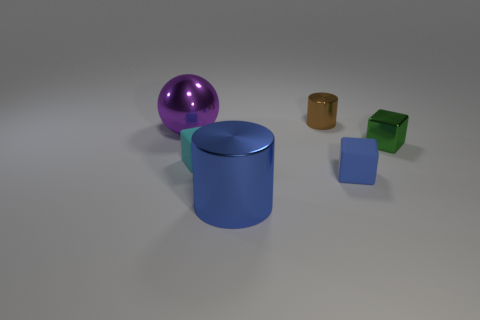Subtract all small matte blocks. How many blocks are left? 1 Subtract 2 cylinders. How many cylinders are left? 0 Add 3 small cubes. How many small cubes are left? 6 Add 4 small rubber spheres. How many small rubber spheres exist? 4 Add 2 big blue metal things. How many objects exist? 8 Subtract all green blocks. How many blocks are left? 2 Subtract 1 purple balls. How many objects are left? 5 Subtract all cylinders. How many objects are left? 4 Subtract all yellow cylinders. Subtract all red cubes. How many cylinders are left? 2 Subtract all red spheres. How many blue cylinders are left? 1 